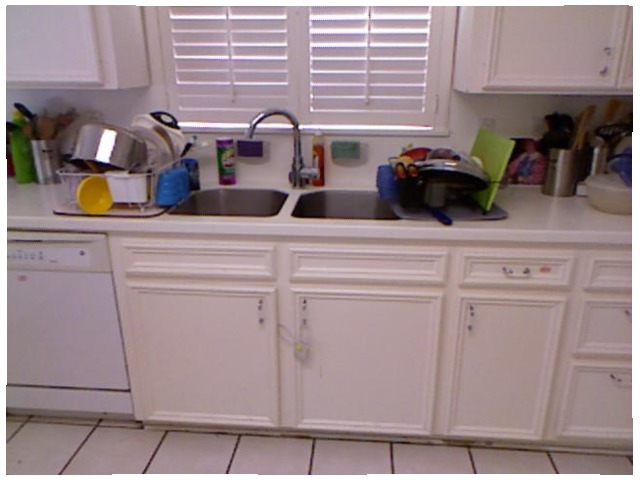<image>
Can you confirm if the sink is in front of the window? Yes. The sink is positioned in front of the window, appearing closer to the camera viewpoint. Where is the shutter in relation to the cabinet? Is it on the cabinet? No. The shutter is not positioned on the cabinet. They may be near each other, but the shutter is not supported by or resting on top of the cabinet. Is there a tap next to the bowl? No. The tap is not positioned next to the bowl. They are located in different areas of the scene. 